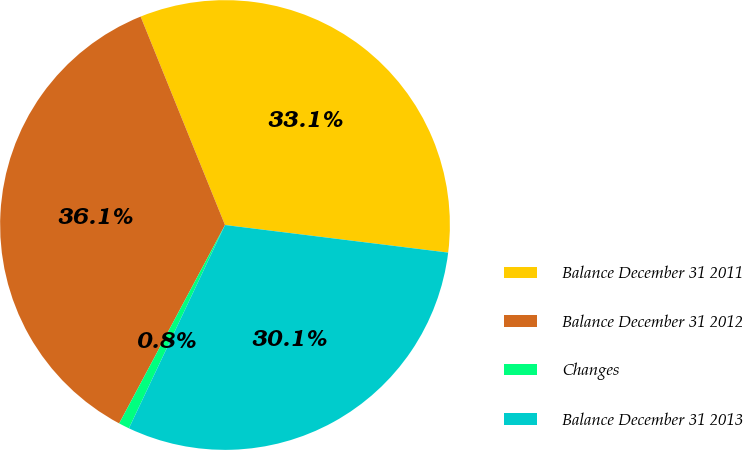<chart> <loc_0><loc_0><loc_500><loc_500><pie_chart><fcel>Balance December 31 2011<fcel>Balance December 31 2012<fcel>Changes<fcel>Balance December 31 2013<nl><fcel>33.08%<fcel>36.08%<fcel>0.77%<fcel>30.07%<nl></chart> 